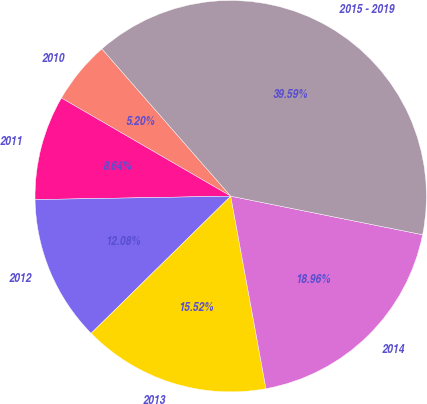Convert chart to OTSL. <chart><loc_0><loc_0><loc_500><loc_500><pie_chart><fcel>2010<fcel>2011<fcel>2012<fcel>2013<fcel>2014<fcel>2015 - 2019<nl><fcel>5.2%<fcel>8.64%<fcel>12.08%<fcel>15.52%<fcel>18.96%<fcel>39.59%<nl></chart> 